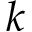Convert formula to latex. <formula><loc_0><loc_0><loc_500><loc_500>k</formula> 